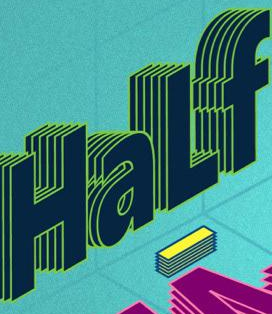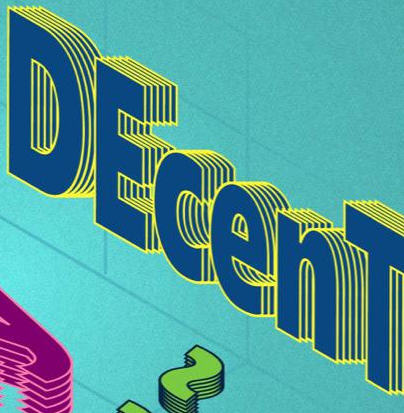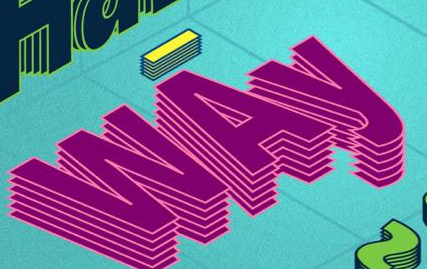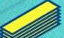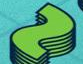What text appears in these images from left to right, separated by a semicolon? HaLf; DEcenT; WAy; -; ~ 